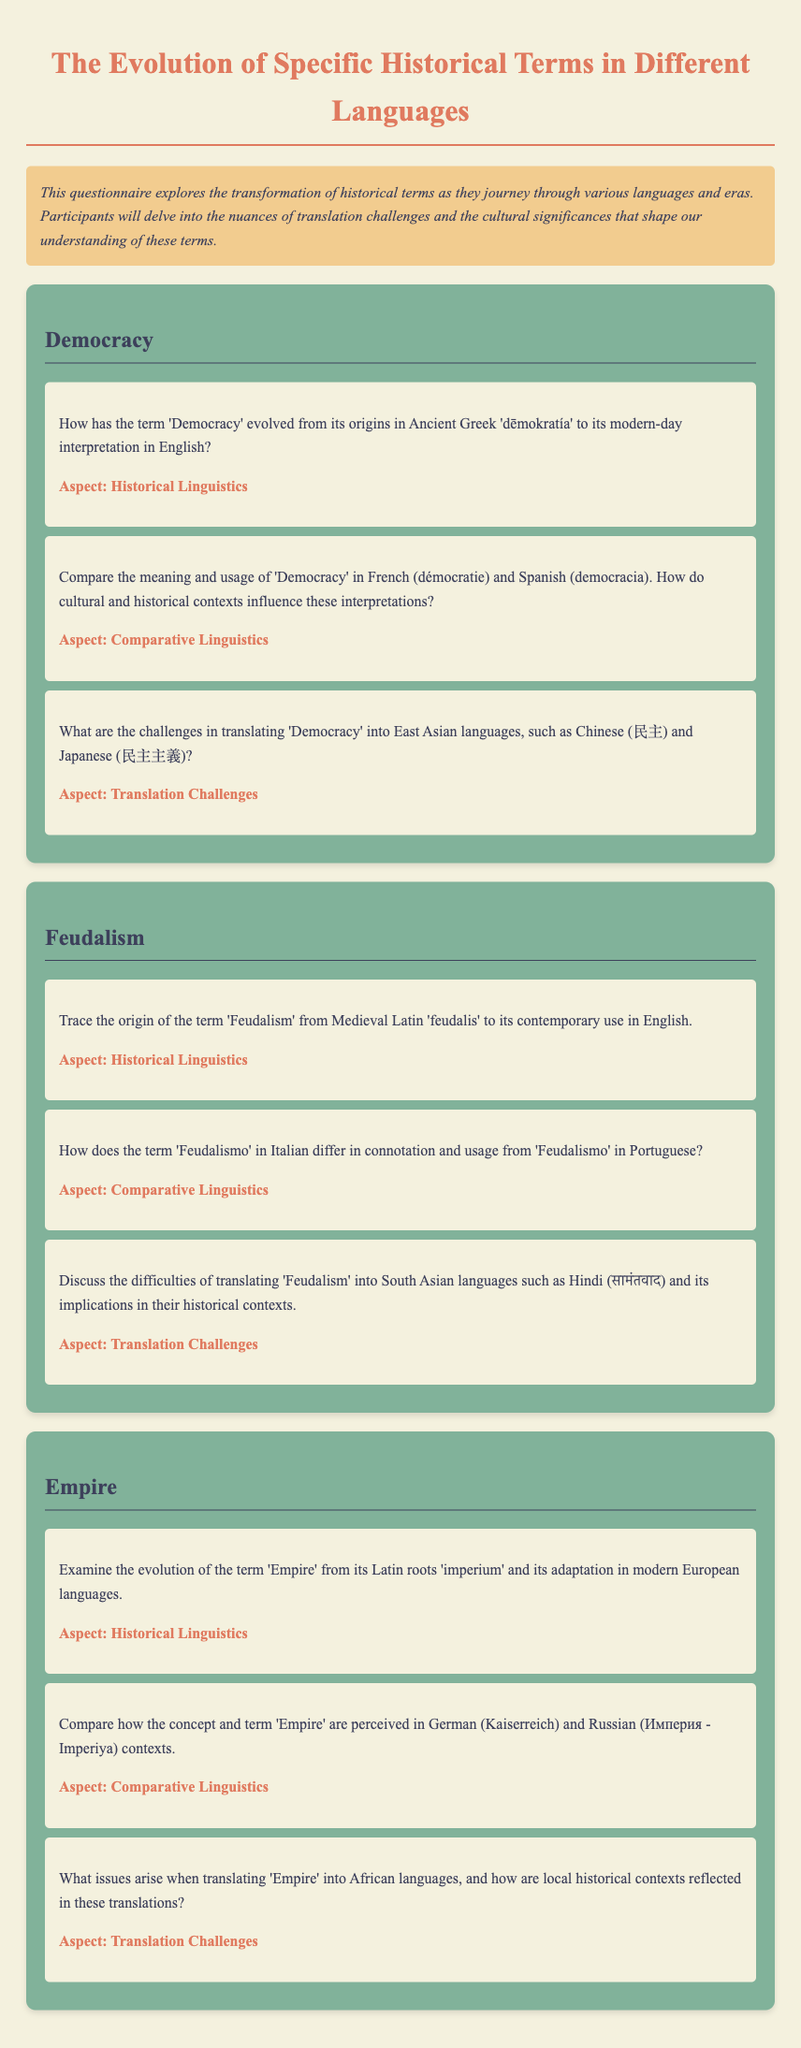How has the term 'Democracy' evolved from its origins in Ancient Greek? The document states that the term 'Democracy' originated from Ancient Greek 'dēmokratía'.
Answer: 'dēmokratía' What is the term for 'Feudalism' in Portuguese? The document mentions that the term for 'Feudalism' in Portuguese is 'Feudalismo'.
Answer: Feudalismo What is the South Asian term for 'Feudalism' in Hindi? The document indicates that the term for 'Feudalism' in Hindi is सामंतवाद.
Answer: सामंतवाद Which languages are discussed regarding the translation of 'Empire'? The document lists German and Russian in relation to the term 'Empire'.
Answer: German and Russian What aspect does the document focus on when discussing 'Democracy'? The document emphasizes "Historical Linguistics" as an aspect for 'Democracy'.
Answer: Historical Linguistics 